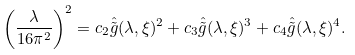<formula> <loc_0><loc_0><loc_500><loc_500>\left ( \frac { \lambda } { 1 6 \pi ^ { 2 } } \right ) ^ { 2 } = c _ { 2 } \hat { \tilde { g } } ( \lambda , \xi ) ^ { 2 } + c _ { 3 } \hat { \tilde { g } } ( \lambda , \xi ) ^ { 3 } + c _ { 4 } \hat { \tilde { g } } ( \lambda , \xi ) ^ { 4 } .</formula> 